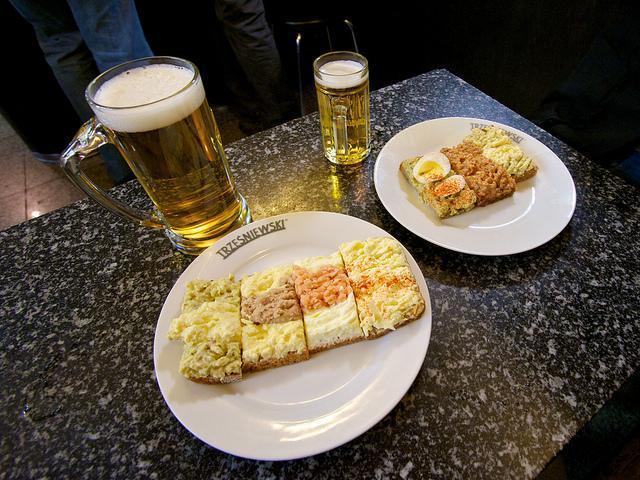How many cups are there?
Give a very brief answer. 2. How many sandwiches are in the picture?
Give a very brief answer. 3. 